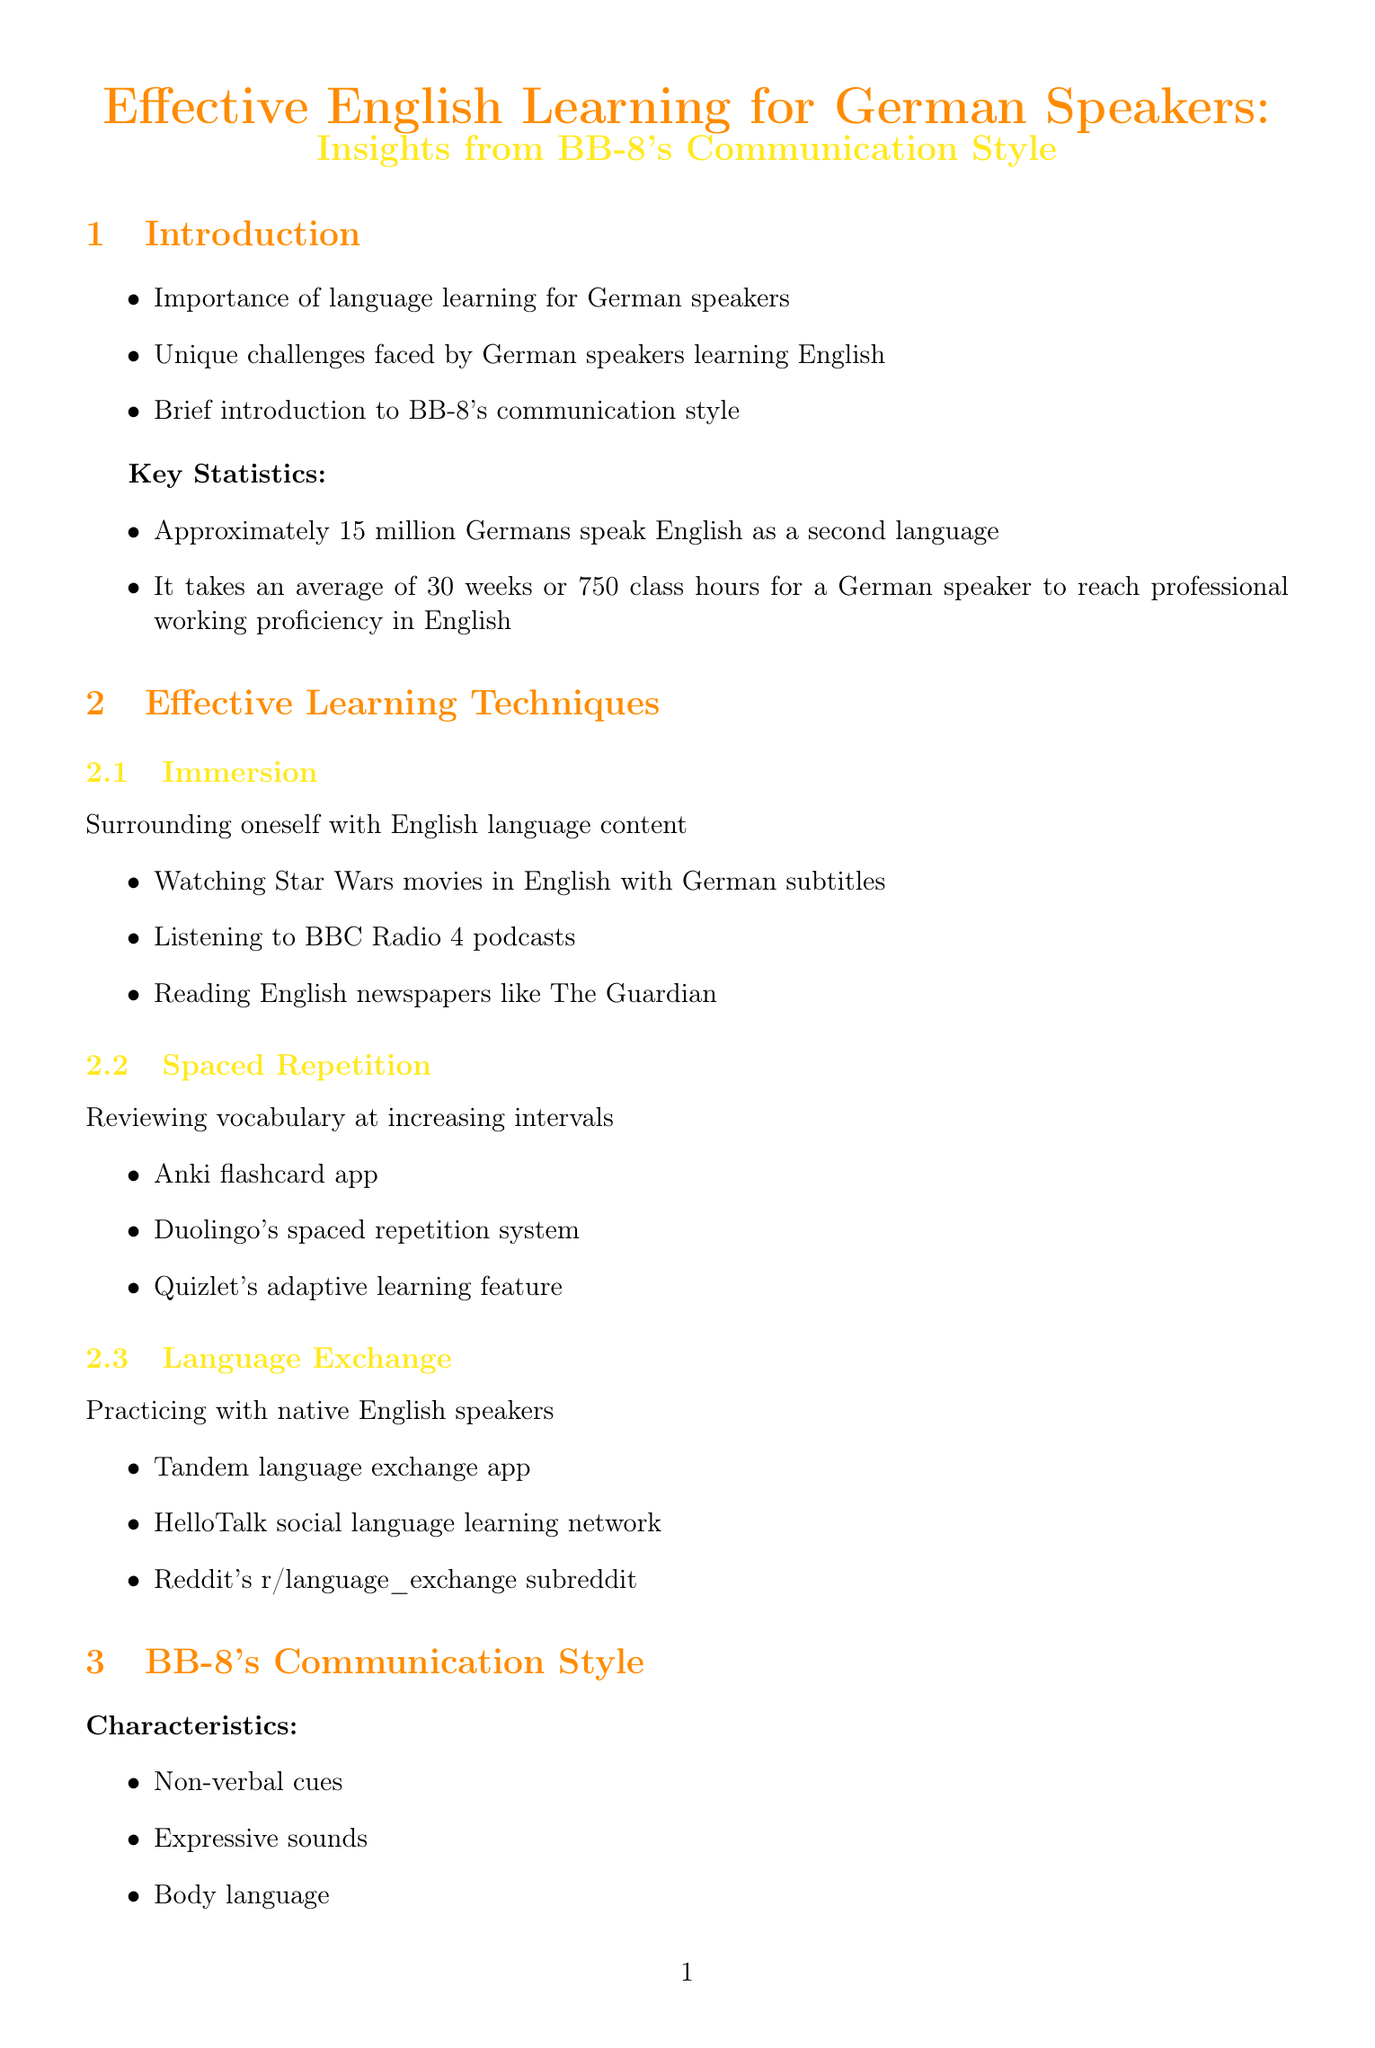What is the average time to fluency for German speakers learning English? The average time to fluency is found in the statistics section, which states it takes 30 weeks or 750 class hours.
Answer: 30 weeks How many German speakers speak English as a second language? The number of German speakers learning English is mentioned in the statistics section.
Answer: Approximately 15 million What is an effective learning technique involving surrounding oneself with English content? This technique focuses on immersing in the English language, emphasizing the importance of language exposure.
Answer: Immersion What challenge involves the example of the German word 'aktuell'? This challenge relates to words that appear similar but have different meanings in English, often confusing learners.
Answer: False friends What is one resource for language learning mentioned in the document? The resources section provides several tools for learning, and one of them is commonly recognized.
Answer: Babbel How can one practice rising and falling intonation patterns in English? This exercise encourages learners to focus on vocal inflections in their speech, similar to BB-8's style of communication.
Answer: Practice rising and falling intonation patterns Which app is suggested for spaced repetition? This app is a popular choice among language learners for reviewing vocabulary effectively.
Answer: Anki What motivational quote is included in the conclusion? The quote encourages commitment in the learning process and serves as inspiration from a well-known character.
Answer: Do. Or do not. There is no try 